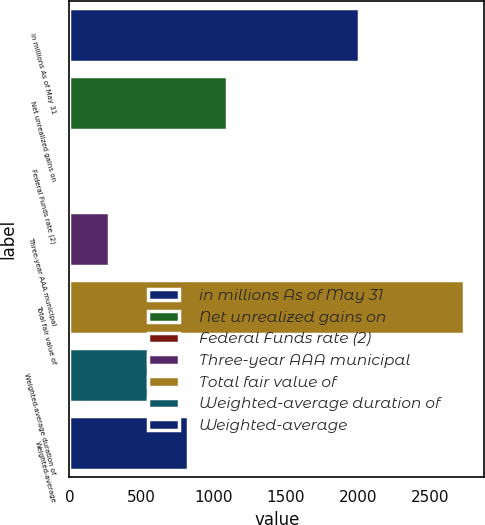<chart> <loc_0><loc_0><loc_500><loc_500><bar_chart><fcel>in millions As of May 31<fcel>Net unrealized gains on<fcel>Federal Funds rate (2)<fcel>Three-year AAA municipal<fcel>Total fair value of<fcel>Weighted-average duration of<fcel>Weighted-average<nl><fcel>2011<fcel>1095.03<fcel>0.25<fcel>273.94<fcel>2737.2<fcel>547.63<fcel>821.33<nl></chart> 